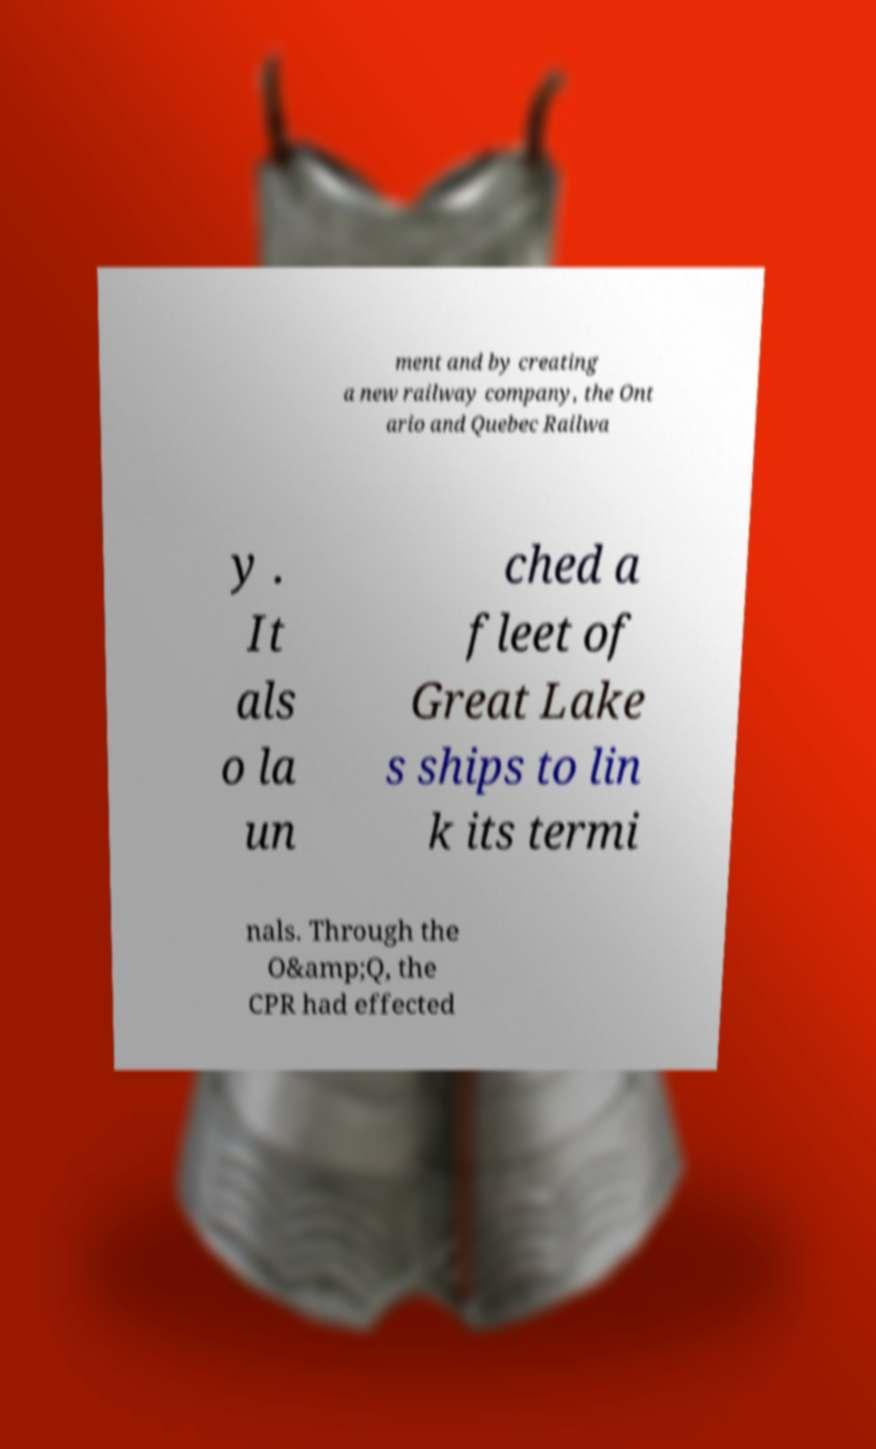Please identify and transcribe the text found in this image. ment and by creating a new railway company, the Ont ario and Quebec Railwa y . It als o la un ched a fleet of Great Lake s ships to lin k its termi nals. Through the O&amp;Q, the CPR had effected 